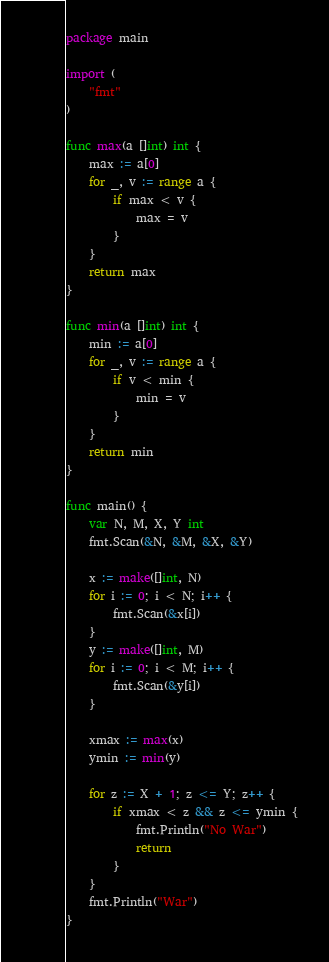<code> <loc_0><loc_0><loc_500><loc_500><_Go_>package main

import (
	"fmt"
)

func max(a []int) int {
	max := a[0]
	for _, v := range a {
		if max < v {
			max = v
		}
	}
	return max
}

func min(a []int) int {
	min := a[0]
	for _, v := range a {
		if v < min {
			min = v
		}
	}
	return min
}

func main() {
	var N, M, X, Y int
	fmt.Scan(&N, &M, &X, &Y)

	x := make([]int, N)
	for i := 0; i < N; i++ {
		fmt.Scan(&x[i])
	}
	y := make([]int, M)
	for i := 0; i < M; i++ {
		fmt.Scan(&y[i])
	}

	xmax := max(x)
	ymin := min(y)

	for z := X + 1; z <= Y; z++ {
		if xmax < z && z <= ymin {
			fmt.Println("No War")
			return
		}
	}
	fmt.Println("War")
}
</code> 